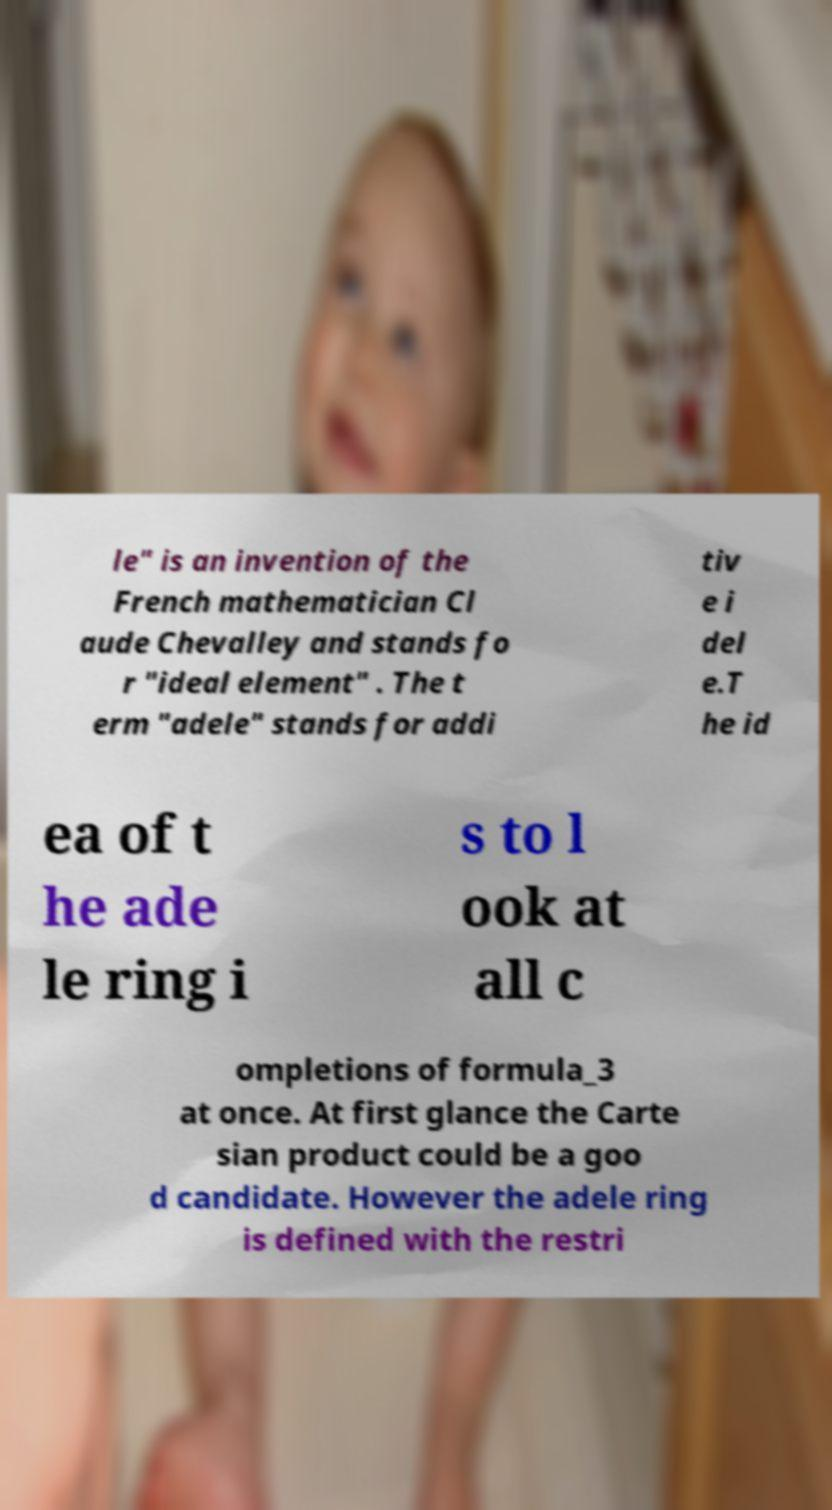I need the written content from this picture converted into text. Can you do that? le" is an invention of the French mathematician Cl aude Chevalley and stands fo r "ideal element" . The t erm "adele" stands for addi tiv e i del e.T he id ea of t he ade le ring i s to l ook at all c ompletions of formula_3 at once. At first glance the Carte sian product could be a goo d candidate. However the adele ring is defined with the restri 